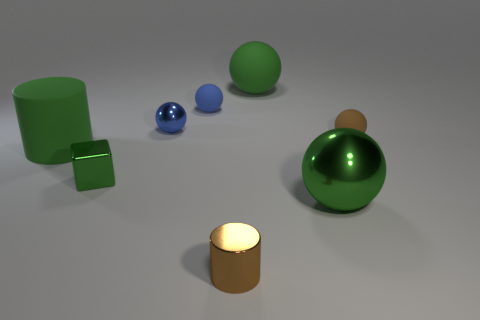Subtract all large matte balls. How many balls are left? 4 Add 2 green matte cylinders. How many objects exist? 10 Subtract all spheres. How many objects are left? 3 Subtract all brown spheres. How many spheres are left? 4 Add 6 green cubes. How many green cubes exist? 7 Subtract 2 blue balls. How many objects are left? 6 Subtract 1 blocks. How many blocks are left? 0 Subtract all brown blocks. Subtract all yellow cylinders. How many blocks are left? 1 Subtract all cyan cylinders. How many blue blocks are left? 0 Subtract all tiny blue objects. Subtract all cyan shiny cylinders. How many objects are left? 6 